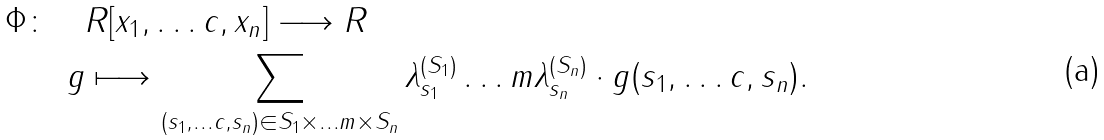<formula> <loc_0><loc_0><loc_500><loc_500>\Phi \colon \quad & R [ x _ { 1 } , \dots c , x _ { n } ] \longrightarrow R \\ g & \longmapsto \sum _ { ( s _ { 1 } , \dots c , s _ { n } ) \in S _ { 1 } \times \dots m \times S _ { n } } \lambda _ { s _ { 1 } } ^ { ( S _ { 1 } ) } \dots m \lambda _ { s _ { n } } ^ { ( S _ { n } ) } \cdot g ( s _ { 1 } , \dots c , s _ { n } ) .</formula> 